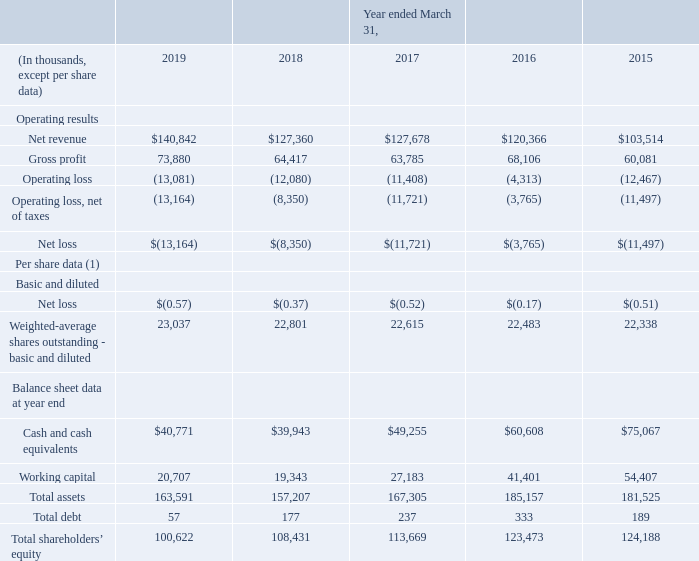Item 6. Selected Financial Data.
The following selected consolidated financial and operating data was derived from our audited consolidated financial statements. The selected financial data should be read in conjunction with the Consolidated Financial Statements and Notes thereto, and Item 7 contained in Part II of this Annual Report.
(1) When a loss is reported, the denominator of diluted earnings per share cannot be adjusted for the dilutive impact of share-based compensation awards because doing so would be anti-dilutive. In addition, when a loss from continuing operations is reported, adjusting the denominator of diluted earnings per share would also be anti-dilutive to the loss per share, even if the entity has net income after adjusting for a discontinued operation.
Therefore, for all periods presented, basic weighted-average shares outstanding were used in calculating the diluted net loss per share.
What is the adjustment made to the denominator when loss is reported? The denominator of diluted earnings per share cannot be adjusted for the dilutive impact of share-based compensation awards because doing so would be anti-dilutive. What calculation is used for diluted net loss per share? Basic weighted-average shares outstanding. What was the net revenue in 2019?
Answer scale should be: thousand. 140,842. What was the increase / (decrease) in the net revenue from 2018 to 2019?
Answer scale should be: thousand. 140,842 - 127,360
Answer: 13482. What is the average gross profit for 2018 and 2019?
Answer scale should be: thousand. (73,880 + 64,417) / 2
Answer: 69148.5. What is the average operating loss for 2018 and 2019?
Answer scale should be: thousand. -(13,081 + 12,080) / 2
Answer: -12580.5. 